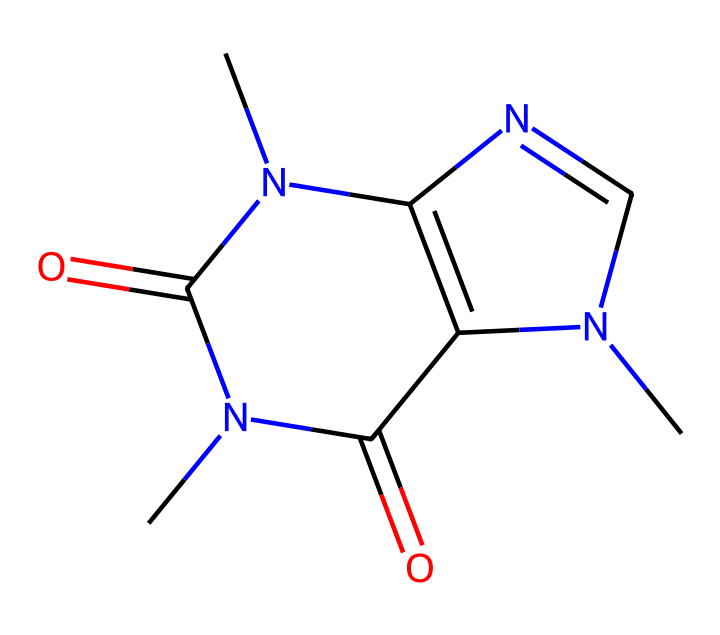What is the molecular formula of caffeine? To determine the molecular formula, we can count the number of each type of atom in the chemical structure represented by the SMILES. The structure shows eight carbon (C) atoms, ten hydrogen (H) atoms, four nitrogen (N) atoms, and two oxygen (O) atoms, leading to the formula C8H10N4O2.
Answer: C8H10N4O2 How many nitrogen atoms are in the structure? By examining the SMILES representation, we can identify the nitrogen (N) atoms. There are four occurrences of nitrogen in the structure.
Answer: 4 What type of compound is caffeine classified as? Caffeine is classified as an alkaloid, which can be inferred from the presence of multiple nitrogen atoms in its structure that are characteristic of this type of compound.
Answer: alkaloid What is the number of rings in the caffeine structure? In the SMILES, we can identify that there are two cyclic parts in the structure. The presence of "1" and "2" in the SMILES indicates that two rings are formed. Hence, there are two rings in the caffeine molecule.
Answer: 2 What functional groups are present in caffeine? The structure contains nitrogen atoms that are part of amine groups and carbonyl groups (C=O). The presence of these functional groups is typical for a molecule like caffeine, which contributes to its biological activity.
Answer: amine and carbonyl How does the structure of caffeine contribute to its stimulant properties? The arrangement of nitrogen atoms in a bicyclic structure allows caffeine to interact effectively with adenosine receptors in the brain, blocking the effects of adenosine and promoting wakefulness. This structural feature is essential for its stimulant effects.
Answer: bicyclic structure 